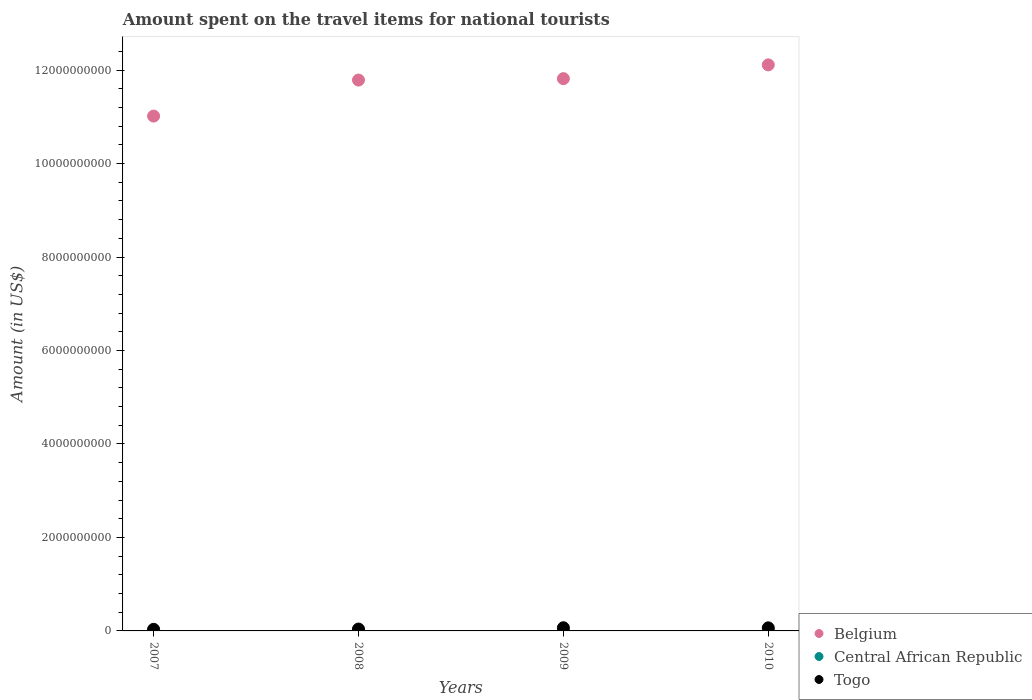How many different coloured dotlines are there?
Make the answer very short. 3. What is the amount spent on the travel items for national tourists in Togo in 2008?
Offer a very short reply. 4.00e+07. Across all years, what is the maximum amount spent on the travel items for national tourists in Belgium?
Keep it short and to the point. 1.21e+1. Across all years, what is the minimum amount spent on the travel items for national tourists in Belgium?
Make the answer very short. 1.10e+1. In which year was the amount spent on the travel items for national tourists in Central African Republic maximum?
Provide a short and direct response. 2010. What is the total amount spent on the travel items for national tourists in Belgium in the graph?
Ensure brevity in your answer.  4.67e+1. What is the difference between the amount spent on the travel items for national tourists in Belgium in 2008 and that in 2010?
Provide a succinct answer. -3.25e+08. What is the difference between the amount spent on the travel items for national tourists in Belgium in 2009 and the amount spent on the travel items for national tourists in Central African Republic in 2007?
Make the answer very short. 1.18e+1. What is the average amount spent on the travel items for national tourists in Togo per year?
Your response must be concise. 5.20e+07. In the year 2009, what is the difference between the amount spent on the travel items for national tourists in Togo and amount spent on the travel items for national tourists in Central African Republic?
Ensure brevity in your answer.  6.35e+07. In how many years, is the amount spent on the travel items for national tourists in Central African Republic greater than 7200000000 US$?
Your answer should be compact. 0. What is the ratio of the amount spent on the travel items for national tourists in Belgium in 2008 to that in 2009?
Keep it short and to the point. 1. Is the amount spent on the travel items for national tourists in Togo in 2009 less than that in 2010?
Give a very brief answer. No. Is the difference between the amount spent on the travel items for national tourists in Togo in 2009 and 2010 greater than the difference between the amount spent on the travel items for national tourists in Central African Republic in 2009 and 2010?
Make the answer very short. Yes. What is the difference between the highest and the second highest amount spent on the travel items for national tourists in Belgium?
Offer a very short reply. 2.95e+08. What is the difference between the highest and the lowest amount spent on the travel items for national tourists in Togo?
Make the answer very short. 3.40e+07. In how many years, is the amount spent on the travel items for national tourists in Togo greater than the average amount spent on the travel items for national tourists in Togo taken over all years?
Your response must be concise. 2. Is the sum of the amount spent on the travel items for national tourists in Belgium in 2009 and 2010 greater than the maximum amount spent on the travel items for national tourists in Togo across all years?
Provide a short and direct response. Yes. Does the amount spent on the travel items for national tourists in Belgium monotonically increase over the years?
Your answer should be very brief. Yes. How many dotlines are there?
Ensure brevity in your answer.  3. What is the difference between two consecutive major ticks on the Y-axis?
Offer a terse response. 2.00e+09. Are the values on the major ticks of Y-axis written in scientific E-notation?
Make the answer very short. No. Does the graph contain grids?
Your answer should be very brief. No. Where does the legend appear in the graph?
Offer a terse response. Bottom right. How many legend labels are there?
Ensure brevity in your answer.  3. What is the title of the graph?
Keep it short and to the point. Amount spent on the travel items for national tourists. What is the label or title of the X-axis?
Your response must be concise. Years. What is the label or title of the Y-axis?
Your response must be concise. Amount (in US$). What is the Amount (in US$) in Belgium in 2007?
Keep it short and to the point. 1.10e+1. What is the Amount (in US$) in Central African Republic in 2007?
Your response must be concise. 8.40e+06. What is the Amount (in US$) of Togo in 2007?
Ensure brevity in your answer.  3.40e+07. What is the Amount (in US$) in Belgium in 2008?
Your answer should be compact. 1.18e+1. What is the Amount (in US$) of Central African Republic in 2008?
Ensure brevity in your answer.  9.00e+06. What is the Amount (in US$) in Togo in 2008?
Offer a very short reply. 4.00e+07. What is the Amount (in US$) of Belgium in 2009?
Make the answer very short. 1.18e+1. What is the Amount (in US$) of Central African Republic in 2009?
Your answer should be compact. 4.50e+06. What is the Amount (in US$) of Togo in 2009?
Provide a short and direct response. 6.80e+07. What is the Amount (in US$) in Belgium in 2010?
Ensure brevity in your answer.  1.21e+1. What is the Amount (in US$) of Central African Republic in 2010?
Provide a short and direct response. 1.10e+07. What is the Amount (in US$) in Togo in 2010?
Keep it short and to the point. 6.60e+07. Across all years, what is the maximum Amount (in US$) of Belgium?
Your response must be concise. 1.21e+1. Across all years, what is the maximum Amount (in US$) in Central African Republic?
Offer a very short reply. 1.10e+07. Across all years, what is the maximum Amount (in US$) of Togo?
Offer a very short reply. 6.80e+07. Across all years, what is the minimum Amount (in US$) in Belgium?
Offer a terse response. 1.10e+1. Across all years, what is the minimum Amount (in US$) in Central African Republic?
Make the answer very short. 4.50e+06. Across all years, what is the minimum Amount (in US$) in Togo?
Keep it short and to the point. 3.40e+07. What is the total Amount (in US$) in Belgium in the graph?
Give a very brief answer. 4.67e+1. What is the total Amount (in US$) of Central African Republic in the graph?
Provide a succinct answer. 3.29e+07. What is the total Amount (in US$) in Togo in the graph?
Ensure brevity in your answer.  2.08e+08. What is the difference between the Amount (in US$) of Belgium in 2007 and that in 2008?
Provide a succinct answer. -7.71e+08. What is the difference between the Amount (in US$) of Central African Republic in 2007 and that in 2008?
Your answer should be very brief. -6.00e+05. What is the difference between the Amount (in US$) in Togo in 2007 and that in 2008?
Ensure brevity in your answer.  -6.00e+06. What is the difference between the Amount (in US$) in Belgium in 2007 and that in 2009?
Offer a very short reply. -8.01e+08. What is the difference between the Amount (in US$) in Central African Republic in 2007 and that in 2009?
Offer a terse response. 3.90e+06. What is the difference between the Amount (in US$) in Togo in 2007 and that in 2009?
Provide a succinct answer. -3.40e+07. What is the difference between the Amount (in US$) in Belgium in 2007 and that in 2010?
Offer a terse response. -1.10e+09. What is the difference between the Amount (in US$) in Central African Republic in 2007 and that in 2010?
Your answer should be compact. -2.60e+06. What is the difference between the Amount (in US$) in Togo in 2007 and that in 2010?
Keep it short and to the point. -3.20e+07. What is the difference between the Amount (in US$) of Belgium in 2008 and that in 2009?
Ensure brevity in your answer.  -3.00e+07. What is the difference between the Amount (in US$) in Central African Republic in 2008 and that in 2009?
Ensure brevity in your answer.  4.50e+06. What is the difference between the Amount (in US$) in Togo in 2008 and that in 2009?
Offer a terse response. -2.80e+07. What is the difference between the Amount (in US$) in Belgium in 2008 and that in 2010?
Give a very brief answer. -3.25e+08. What is the difference between the Amount (in US$) of Togo in 2008 and that in 2010?
Provide a succinct answer. -2.60e+07. What is the difference between the Amount (in US$) of Belgium in 2009 and that in 2010?
Provide a succinct answer. -2.95e+08. What is the difference between the Amount (in US$) of Central African Republic in 2009 and that in 2010?
Give a very brief answer. -6.50e+06. What is the difference between the Amount (in US$) in Belgium in 2007 and the Amount (in US$) in Central African Republic in 2008?
Your answer should be compact. 1.10e+1. What is the difference between the Amount (in US$) in Belgium in 2007 and the Amount (in US$) in Togo in 2008?
Provide a short and direct response. 1.10e+1. What is the difference between the Amount (in US$) in Central African Republic in 2007 and the Amount (in US$) in Togo in 2008?
Offer a terse response. -3.16e+07. What is the difference between the Amount (in US$) in Belgium in 2007 and the Amount (in US$) in Central African Republic in 2009?
Provide a succinct answer. 1.10e+1. What is the difference between the Amount (in US$) in Belgium in 2007 and the Amount (in US$) in Togo in 2009?
Offer a very short reply. 1.09e+1. What is the difference between the Amount (in US$) of Central African Republic in 2007 and the Amount (in US$) of Togo in 2009?
Make the answer very short. -5.96e+07. What is the difference between the Amount (in US$) in Belgium in 2007 and the Amount (in US$) in Central African Republic in 2010?
Make the answer very short. 1.10e+1. What is the difference between the Amount (in US$) in Belgium in 2007 and the Amount (in US$) in Togo in 2010?
Your answer should be very brief. 1.10e+1. What is the difference between the Amount (in US$) in Central African Republic in 2007 and the Amount (in US$) in Togo in 2010?
Provide a succinct answer. -5.76e+07. What is the difference between the Amount (in US$) of Belgium in 2008 and the Amount (in US$) of Central African Republic in 2009?
Offer a terse response. 1.18e+1. What is the difference between the Amount (in US$) in Belgium in 2008 and the Amount (in US$) in Togo in 2009?
Ensure brevity in your answer.  1.17e+1. What is the difference between the Amount (in US$) in Central African Republic in 2008 and the Amount (in US$) in Togo in 2009?
Ensure brevity in your answer.  -5.90e+07. What is the difference between the Amount (in US$) in Belgium in 2008 and the Amount (in US$) in Central African Republic in 2010?
Give a very brief answer. 1.18e+1. What is the difference between the Amount (in US$) in Belgium in 2008 and the Amount (in US$) in Togo in 2010?
Your answer should be compact. 1.17e+1. What is the difference between the Amount (in US$) of Central African Republic in 2008 and the Amount (in US$) of Togo in 2010?
Your response must be concise. -5.70e+07. What is the difference between the Amount (in US$) of Belgium in 2009 and the Amount (in US$) of Central African Republic in 2010?
Your response must be concise. 1.18e+1. What is the difference between the Amount (in US$) of Belgium in 2009 and the Amount (in US$) of Togo in 2010?
Your answer should be very brief. 1.18e+1. What is the difference between the Amount (in US$) in Central African Republic in 2009 and the Amount (in US$) in Togo in 2010?
Your response must be concise. -6.15e+07. What is the average Amount (in US$) of Belgium per year?
Offer a very short reply. 1.17e+1. What is the average Amount (in US$) in Central African Republic per year?
Ensure brevity in your answer.  8.22e+06. What is the average Amount (in US$) in Togo per year?
Give a very brief answer. 5.20e+07. In the year 2007, what is the difference between the Amount (in US$) of Belgium and Amount (in US$) of Central African Republic?
Provide a succinct answer. 1.10e+1. In the year 2007, what is the difference between the Amount (in US$) of Belgium and Amount (in US$) of Togo?
Offer a terse response. 1.10e+1. In the year 2007, what is the difference between the Amount (in US$) of Central African Republic and Amount (in US$) of Togo?
Your answer should be very brief. -2.56e+07. In the year 2008, what is the difference between the Amount (in US$) of Belgium and Amount (in US$) of Central African Republic?
Your response must be concise. 1.18e+1. In the year 2008, what is the difference between the Amount (in US$) of Belgium and Amount (in US$) of Togo?
Keep it short and to the point. 1.17e+1. In the year 2008, what is the difference between the Amount (in US$) of Central African Republic and Amount (in US$) of Togo?
Your answer should be compact. -3.10e+07. In the year 2009, what is the difference between the Amount (in US$) of Belgium and Amount (in US$) of Central African Republic?
Keep it short and to the point. 1.18e+1. In the year 2009, what is the difference between the Amount (in US$) of Belgium and Amount (in US$) of Togo?
Keep it short and to the point. 1.18e+1. In the year 2009, what is the difference between the Amount (in US$) in Central African Republic and Amount (in US$) in Togo?
Your answer should be very brief. -6.35e+07. In the year 2010, what is the difference between the Amount (in US$) in Belgium and Amount (in US$) in Central African Republic?
Ensure brevity in your answer.  1.21e+1. In the year 2010, what is the difference between the Amount (in US$) in Belgium and Amount (in US$) in Togo?
Provide a succinct answer. 1.20e+1. In the year 2010, what is the difference between the Amount (in US$) in Central African Republic and Amount (in US$) in Togo?
Offer a very short reply. -5.50e+07. What is the ratio of the Amount (in US$) in Belgium in 2007 to that in 2008?
Keep it short and to the point. 0.93. What is the ratio of the Amount (in US$) of Central African Republic in 2007 to that in 2008?
Provide a short and direct response. 0.93. What is the ratio of the Amount (in US$) in Belgium in 2007 to that in 2009?
Provide a succinct answer. 0.93. What is the ratio of the Amount (in US$) of Central African Republic in 2007 to that in 2009?
Your answer should be very brief. 1.87. What is the ratio of the Amount (in US$) in Belgium in 2007 to that in 2010?
Ensure brevity in your answer.  0.91. What is the ratio of the Amount (in US$) of Central African Republic in 2007 to that in 2010?
Your answer should be very brief. 0.76. What is the ratio of the Amount (in US$) of Togo in 2007 to that in 2010?
Offer a very short reply. 0.52. What is the ratio of the Amount (in US$) of Belgium in 2008 to that in 2009?
Make the answer very short. 1. What is the ratio of the Amount (in US$) in Togo in 2008 to that in 2009?
Provide a short and direct response. 0.59. What is the ratio of the Amount (in US$) in Belgium in 2008 to that in 2010?
Ensure brevity in your answer.  0.97. What is the ratio of the Amount (in US$) of Central African Republic in 2008 to that in 2010?
Give a very brief answer. 0.82. What is the ratio of the Amount (in US$) of Togo in 2008 to that in 2010?
Give a very brief answer. 0.61. What is the ratio of the Amount (in US$) of Belgium in 2009 to that in 2010?
Make the answer very short. 0.98. What is the ratio of the Amount (in US$) of Central African Republic in 2009 to that in 2010?
Keep it short and to the point. 0.41. What is the ratio of the Amount (in US$) in Togo in 2009 to that in 2010?
Keep it short and to the point. 1.03. What is the difference between the highest and the second highest Amount (in US$) in Belgium?
Provide a succinct answer. 2.95e+08. What is the difference between the highest and the second highest Amount (in US$) of Central African Republic?
Your answer should be very brief. 2.00e+06. What is the difference between the highest and the lowest Amount (in US$) of Belgium?
Keep it short and to the point. 1.10e+09. What is the difference between the highest and the lowest Amount (in US$) of Central African Republic?
Your answer should be compact. 6.50e+06. What is the difference between the highest and the lowest Amount (in US$) of Togo?
Ensure brevity in your answer.  3.40e+07. 